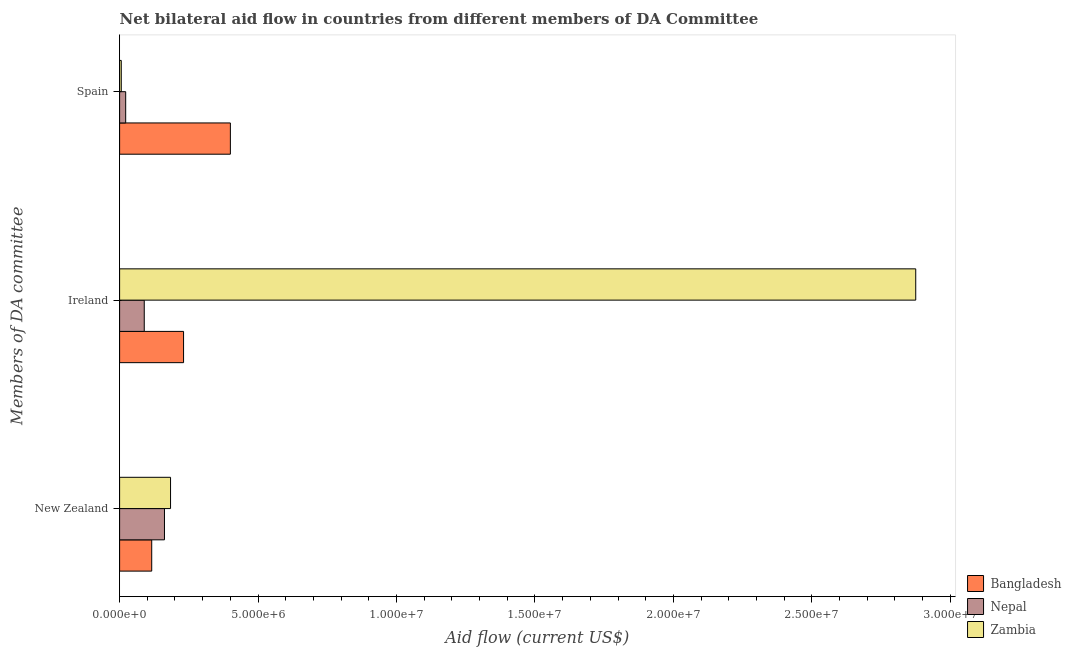How many different coloured bars are there?
Your answer should be very brief. 3. How many bars are there on the 2nd tick from the bottom?
Ensure brevity in your answer.  3. What is the amount of aid provided by new zealand in Nepal?
Offer a very short reply. 1.62e+06. Across all countries, what is the maximum amount of aid provided by ireland?
Ensure brevity in your answer.  2.88e+07. Across all countries, what is the minimum amount of aid provided by new zealand?
Your response must be concise. 1.16e+06. In which country was the amount of aid provided by ireland maximum?
Give a very brief answer. Zambia. In which country was the amount of aid provided by spain minimum?
Provide a succinct answer. Zambia. What is the total amount of aid provided by spain in the graph?
Provide a short and direct response. 4.28e+06. What is the difference between the amount of aid provided by spain in Bangladesh and that in Zambia?
Ensure brevity in your answer.  3.94e+06. What is the difference between the amount of aid provided by ireland in Nepal and the amount of aid provided by new zealand in Bangladesh?
Offer a terse response. -2.70e+05. What is the average amount of aid provided by ireland per country?
Your answer should be very brief. 1.06e+07. What is the difference between the amount of aid provided by new zealand and amount of aid provided by ireland in Nepal?
Your response must be concise. 7.30e+05. In how many countries, is the amount of aid provided by ireland greater than 22000000 US$?
Give a very brief answer. 1. What is the ratio of the amount of aid provided by ireland in Bangladesh to that in Nepal?
Provide a succinct answer. 2.6. Is the amount of aid provided by ireland in Zambia less than that in Bangladesh?
Your answer should be compact. No. What is the difference between the highest and the second highest amount of aid provided by new zealand?
Make the answer very short. 2.20e+05. What is the difference between the highest and the lowest amount of aid provided by ireland?
Offer a very short reply. 2.79e+07. What does the 3rd bar from the bottom in New Zealand represents?
Your response must be concise. Zambia. Is it the case that in every country, the sum of the amount of aid provided by new zealand and amount of aid provided by ireland is greater than the amount of aid provided by spain?
Provide a short and direct response. No. How many bars are there?
Your answer should be compact. 9. Are all the bars in the graph horizontal?
Keep it short and to the point. Yes. Does the graph contain any zero values?
Your answer should be very brief. No. What is the title of the graph?
Provide a succinct answer. Net bilateral aid flow in countries from different members of DA Committee. Does "Mozambique" appear as one of the legend labels in the graph?
Your response must be concise. No. What is the label or title of the Y-axis?
Make the answer very short. Members of DA committee. What is the Aid flow (current US$) of Bangladesh in New Zealand?
Keep it short and to the point. 1.16e+06. What is the Aid flow (current US$) in Nepal in New Zealand?
Make the answer very short. 1.62e+06. What is the Aid flow (current US$) in Zambia in New Zealand?
Make the answer very short. 1.84e+06. What is the Aid flow (current US$) in Bangladesh in Ireland?
Provide a succinct answer. 2.31e+06. What is the Aid flow (current US$) of Nepal in Ireland?
Ensure brevity in your answer.  8.90e+05. What is the Aid flow (current US$) of Zambia in Ireland?
Give a very brief answer. 2.88e+07. What is the Aid flow (current US$) of Bangladesh in Spain?
Make the answer very short. 4.00e+06. What is the Aid flow (current US$) of Nepal in Spain?
Make the answer very short. 2.20e+05. What is the Aid flow (current US$) in Zambia in Spain?
Your answer should be compact. 6.00e+04. Across all Members of DA committee, what is the maximum Aid flow (current US$) in Nepal?
Provide a succinct answer. 1.62e+06. Across all Members of DA committee, what is the maximum Aid flow (current US$) in Zambia?
Your answer should be compact. 2.88e+07. Across all Members of DA committee, what is the minimum Aid flow (current US$) in Bangladesh?
Offer a terse response. 1.16e+06. What is the total Aid flow (current US$) of Bangladesh in the graph?
Provide a succinct answer. 7.47e+06. What is the total Aid flow (current US$) in Nepal in the graph?
Provide a succinct answer. 2.73e+06. What is the total Aid flow (current US$) in Zambia in the graph?
Provide a succinct answer. 3.06e+07. What is the difference between the Aid flow (current US$) of Bangladesh in New Zealand and that in Ireland?
Give a very brief answer. -1.15e+06. What is the difference between the Aid flow (current US$) in Nepal in New Zealand and that in Ireland?
Make the answer very short. 7.30e+05. What is the difference between the Aid flow (current US$) in Zambia in New Zealand and that in Ireland?
Offer a terse response. -2.69e+07. What is the difference between the Aid flow (current US$) in Bangladesh in New Zealand and that in Spain?
Offer a very short reply. -2.84e+06. What is the difference between the Aid flow (current US$) of Nepal in New Zealand and that in Spain?
Make the answer very short. 1.40e+06. What is the difference between the Aid flow (current US$) in Zambia in New Zealand and that in Spain?
Give a very brief answer. 1.78e+06. What is the difference between the Aid flow (current US$) of Bangladesh in Ireland and that in Spain?
Offer a terse response. -1.69e+06. What is the difference between the Aid flow (current US$) in Nepal in Ireland and that in Spain?
Give a very brief answer. 6.70e+05. What is the difference between the Aid flow (current US$) in Zambia in Ireland and that in Spain?
Keep it short and to the point. 2.87e+07. What is the difference between the Aid flow (current US$) in Bangladesh in New Zealand and the Aid flow (current US$) in Nepal in Ireland?
Your answer should be compact. 2.70e+05. What is the difference between the Aid flow (current US$) in Bangladesh in New Zealand and the Aid flow (current US$) in Zambia in Ireland?
Your answer should be very brief. -2.76e+07. What is the difference between the Aid flow (current US$) of Nepal in New Zealand and the Aid flow (current US$) of Zambia in Ireland?
Keep it short and to the point. -2.71e+07. What is the difference between the Aid flow (current US$) in Bangladesh in New Zealand and the Aid flow (current US$) in Nepal in Spain?
Provide a succinct answer. 9.40e+05. What is the difference between the Aid flow (current US$) in Bangladesh in New Zealand and the Aid flow (current US$) in Zambia in Spain?
Offer a terse response. 1.10e+06. What is the difference between the Aid flow (current US$) of Nepal in New Zealand and the Aid flow (current US$) of Zambia in Spain?
Give a very brief answer. 1.56e+06. What is the difference between the Aid flow (current US$) of Bangladesh in Ireland and the Aid flow (current US$) of Nepal in Spain?
Ensure brevity in your answer.  2.09e+06. What is the difference between the Aid flow (current US$) of Bangladesh in Ireland and the Aid flow (current US$) of Zambia in Spain?
Your answer should be very brief. 2.25e+06. What is the difference between the Aid flow (current US$) in Nepal in Ireland and the Aid flow (current US$) in Zambia in Spain?
Make the answer very short. 8.30e+05. What is the average Aid flow (current US$) of Bangladesh per Members of DA committee?
Give a very brief answer. 2.49e+06. What is the average Aid flow (current US$) in Nepal per Members of DA committee?
Offer a terse response. 9.10e+05. What is the average Aid flow (current US$) in Zambia per Members of DA committee?
Offer a terse response. 1.02e+07. What is the difference between the Aid flow (current US$) in Bangladesh and Aid flow (current US$) in Nepal in New Zealand?
Provide a short and direct response. -4.60e+05. What is the difference between the Aid flow (current US$) in Bangladesh and Aid flow (current US$) in Zambia in New Zealand?
Offer a terse response. -6.80e+05. What is the difference between the Aid flow (current US$) in Bangladesh and Aid flow (current US$) in Nepal in Ireland?
Offer a terse response. 1.42e+06. What is the difference between the Aid flow (current US$) of Bangladesh and Aid flow (current US$) of Zambia in Ireland?
Your response must be concise. -2.64e+07. What is the difference between the Aid flow (current US$) of Nepal and Aid flow (current US$) of Zambia in Ireland?
Offer a terse response. -2.79e+07. What is the difference between the Aid flow (current US$) of Bangladesh and Aid flow (current US$) of Nepal in Spain?
Offer a terse response. 3.78e+06. What is the difference between the Aid flow (current US$) of Bangladesh and Aid flow (current US$) of Zambia in Spain?
Keep it short and to the point. 3.94e+06. What is the ratio of the Aid flow (current US$) in Bangladesh in New Zealand to that in Ireland?
Provide a short and direct response. 0.5. What is the ratio of the Aid flow (current US$) of Nepal in New Zealand to that in Ireland?
Provide a short and direct response. 1.82. What is the ratio of the Aid flow (current US$) in Zambia in New Zealand to that in Ireland?
Keep it short and to the point. 0.06. What is the ratio of the Aid flow (current US$) of Bangladesh in New Zealand to that in Spain?
Make the answer very short. 0.29. What is the ratio of the Aid flow (current US$) in Nepal in New Zealand to that in Spain?
Your answer should be very brief. 7.36. What is the ratio of the Aid flow (current US$) of Zambia in New Zealand to that in Spain?
Your response must be concise. 30.67. What is the ratio of the Aid flow (current US$) in Bangladesh in Ireland to that in Spain?
Make the answer very short. 0.58. What is the ratio of the Aid flow (current US$) in Nepal in Ireland to that in Spain?
Your response must be concise. 4.05. What is the ratio of the Aid flow (current US$) in Zambia in Ireland to that in Spain?
Offer a terse response. 479.17. What is the difference between the highest and the second highest Aid flow (current US$) of Bangladesh?
Offer a terse response. 1.69e+06. What is the difference between the highest and the second highest Aid flow (current US$) of Nepal?
Provide a short and direct response. 7.30e+05. What is the difference between the highest and the second highest Aid flow (current US$) in Zambia?
Keep it short and to the point. 2.69e+07. What is the difference between the highest and the lowest Aid flow (current US$) in Bangladesh?
Offer a terse response. 2.84e+06. What is the difference between the highest and the lowest Aid flow (current US$) of Nepal?
Ensure brevity in your answer.  1.40e+06. What is the difference between the highest and the lowest Aid flow (current US$) of Zambia?
Ensure brevity in your answer.  2.87e+07. 